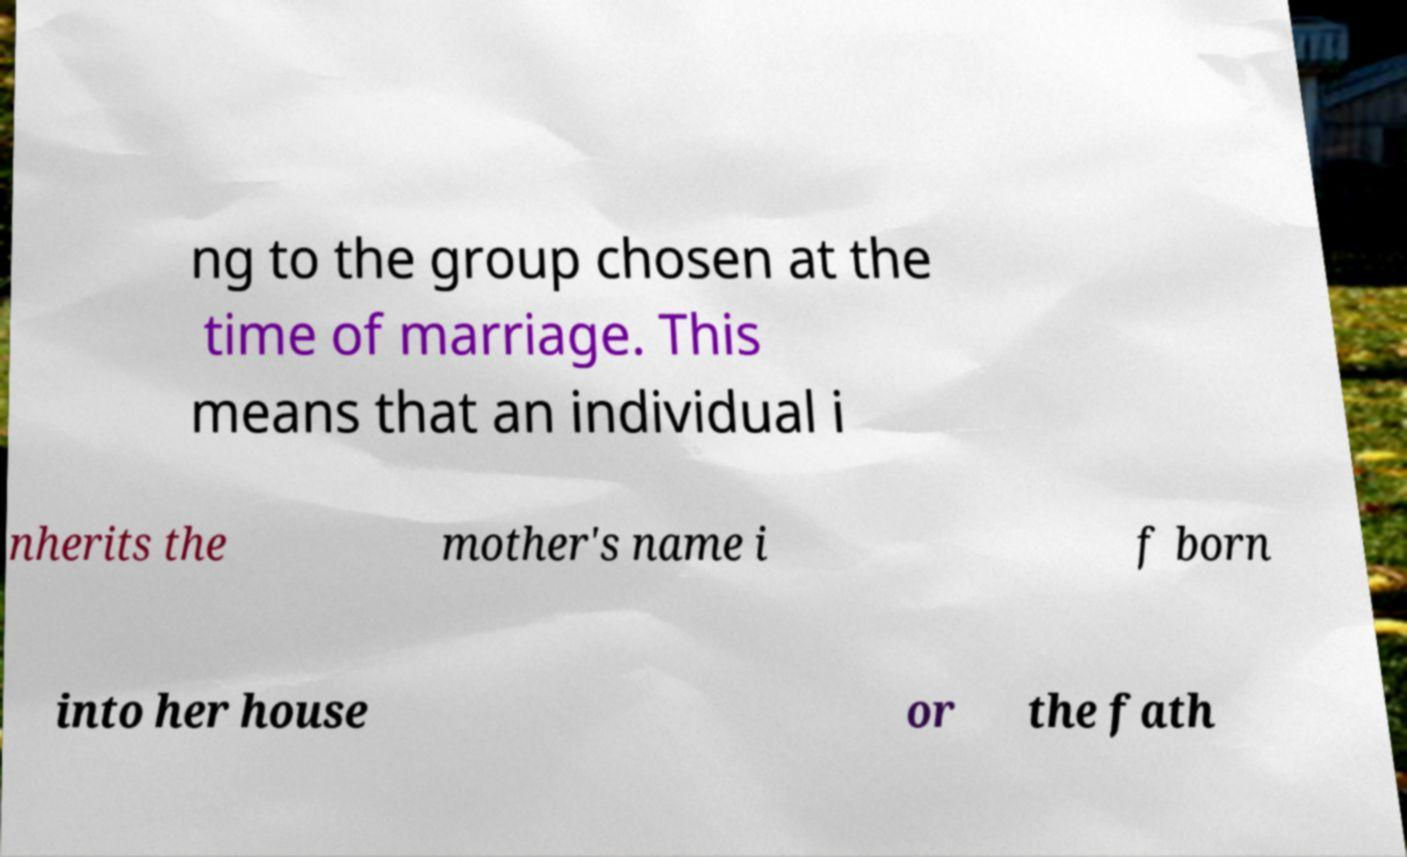What messages or text are displayed in this image? I need them in a readable, typed format. ng to the group chosen at the time of marriage. This means that an individual i nherits the mother's name i f born into her house or the fath 